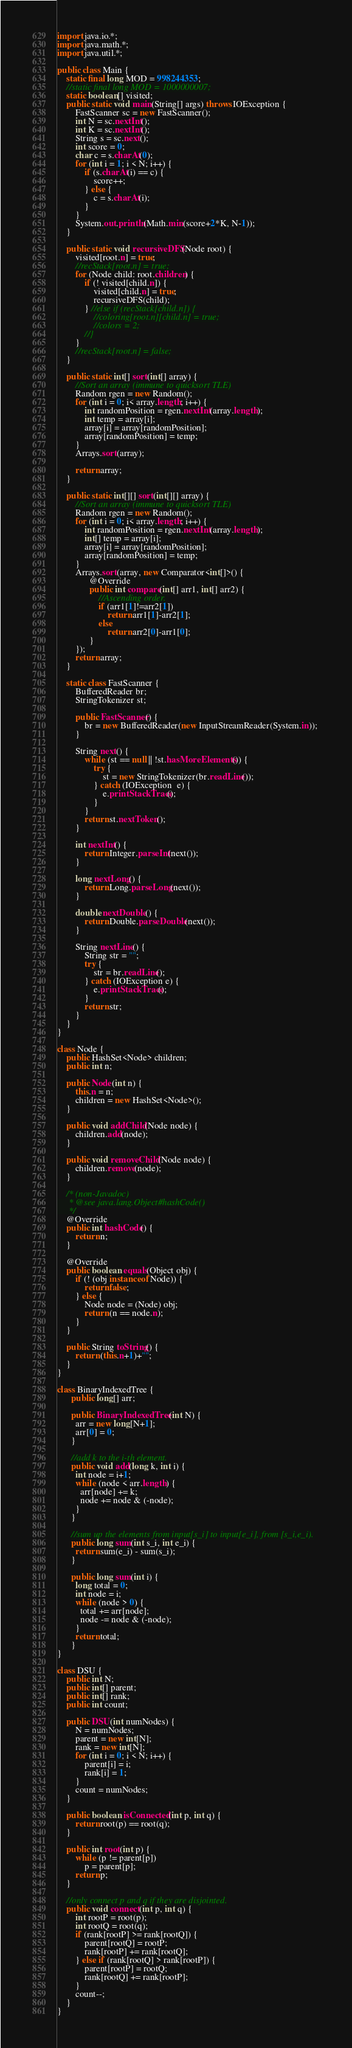<code> <loc_0><loc_0><loc_500><loc_500><_Java_>import java.io.*; 
import java.math.*;
import java.util.*;
 
public class Main {
	static final long MOD = 998244353;
	//static final long MOD = 1000000007;
	static boolean[] visited;
    public static void main(String[] args) throws IOException {
        FastScanner sc = new FastScanner();
        int N = sc.nextInt();
        int K = sc.nextInt();
        String s = sc.next();
    	int score = 0;
    	char c = s.charAt(0);
    	for (int i = 1; i < N; i++) {
    		if (s.charAt(i) == c) {
    			score++;
    		} else {
    			c = s.charAt(i);
    		}
    	}
    	System.out.println(Math.min(score+2*K, N-1));
    }
    
    public static void recursiveDFS(Node root) {
    	visited[root.n] = true;
    	//recStack[root.n] = true;
    	for (Node child: root.children) {
    		if (! visited[child.n]) {
    			visited[child.n] = true;
    			recursiveDFS(child);
    		} //else if (recStack[child.n]) {
    			//coloring[root.n][child.n] = true;
    			//colors = 2;
    		//}
    	}
    	//recStack[root.n] = false;
    }
    
    public static int[] sort(int[] array) {
    	//Sort an array (immune to quicksort TLE)
		Random rgen = new Random();
		for (int i = 0; i< array.length; i++) {
		    int randomPosition = rgen.nextInt(array.length);
		    int temp = array[i];
		    array[i] = array[randomPosition];
		    array[randomPosition] = temp;
		}
		Arrays.sort(array);

		return array;
	}
    
    public static int[][] sort(int[][] array) {
    	//Sort an array (immune to quicksort TLE)
		Random rgen = new Random();
		for (int i = 0; i< array.length; i++) {
		    int randomPosition = rgen.nextInt(array.length);
		    int[] temp = array[i];
		    array[i] = array[randomPosition];
		    array[randomPosition] = temp;
		}
		Arrays.sort(array, new Comparator<int[]>() {
			  @Override
			  public int compare(int[] arr1, int[] arr2) {
				  //Ascending order.
				  if (arr1[1]!=arr2[1])
					  return arr1[1]-arr2[1];
				  else
					  return arr2[0]-arr1[0];
			  }
		});
		return array;
	}
    
    static class FastScanner { 
        BufferedReader br; 
        StringTokenizer st; 
  
        public FastScanner() { 
            br = new BufferedReader(new InputStreamReader(System.in)); 
        } 
  
        String next() { 
            while (st == null || !st.hasMoreElements()) { 
                try { 
                    st = new StringTokenizer(br.readLine());
                } catch (IOException  e) { 
                    e.printStackTrace(); 
                } 
            } 
            return st.nextToken(); 
        } 
  
        int nextInt() { 
            return Integer.parseInt(next()); 
        } 
  
        long nextLong() { 
            return Long.parseLong(next()); 
        } 
  
        double nextDouble() { 
            return Double.parseDouble(next()); 
        } 
  
        String nextLine() { 
            String str = ""; 
            try { 
                str = br.readLine(); 
            } catch (IOException e) {
                e.printStackTrace(); 
            } 
            return str; 
        }
    }
}

class Node {
	public HashSet<Node> children;
	public int n;
	
	public Node(int n) {
		this.n = n;
		children = new HashSet<Node>();
	}
	
	public void addChild(Node node) {
		children.add(node);
	}
	
	public void removeChild(Node node) {
		children.remove(node);
	}

	/* (non-Javadoc)
	 * @see java.lang.Object#hashCode()
	 */
	@Override
	public int hashCode() {
		return n;
	}

	@Override
	public boolean equals(Object obj) {
		if (! (obj instanceof Node)) {
			return false;
		} else {
			Node node = (Node) obj;
			return (n == node.n);
		}
	}
	
	public String toString() {
		return (this.n+1)+"";
	}
}

class BinaryIndexedTree {
	  public long[] arr;
 
	  public BinaryIndexedTree (int N) {
	    arr = new long[N+1];
	    arr[0] = 0;
	  }
 
	  //add k to the i-th element.
	  public void add(long k, int i) {
	    int node = i+1;
	    while (node < arr.length) {
	      arr[node] += k;
	      node += node & (-node);
	    }
	  }
 
	  //sum up the elements from input[s_i] to input[e_i], from [s_i,e_i).
	  public long sum(int s_i, int e_i) {
	    return sum(e_i) - sum(s_i);
	  }
 
	  public long sum(int i) {
	    long total = 0;
	    int node = i;
	    while (node > 0) {
	      total += arr[node];
	      node -= node & (-node);
	    }
	    return total;
	  }
}

class DSU {
	public int N;
	public int[] parent;
	public int[] rank;
	public int count;
	
	public DSU(int numNodes) {
		N = numNodes;
	    parent = new int[N];
	    rank = new int[N];
	    for (int i = 0; i < N; i++) {
	    	parent[i] = i;
	    	rank[i] = 1;
	    }
	    count = numNodes;
	}
	
	public boolean isConnected(int p, int q) {
	    return root(p) == root(q);
	}
	
	public int root(int p) {
		while (p != parent[p])
			p = parent[p];
	    return p;
	}
	
	//only connect p and q if they are disjointed.
	public void connect(int p, int q) {
		int rootP = root(p);
	    int rootQ = root(q);
	    if (rank[rootP] >= rank[rootQ]) {
	    	parent[rootQ] = rootP;
	    	rank[rootP] += rank[rootQ];
	    } else if (rank[rootQ] > rank[rootP]) {
	    	parent[rootP] = rootQ;
	    	rank[rootQ] += rank[rootP];
	    }
	    count--;
	}
}</code> 